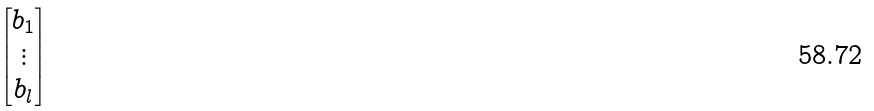<formula> <loc_0><loc_0><loc_500><loc_500>\begin{bmatrix} b _ { 1 } \\ \vdots \\ b _ { l } \end{bmatrix}</formula> 